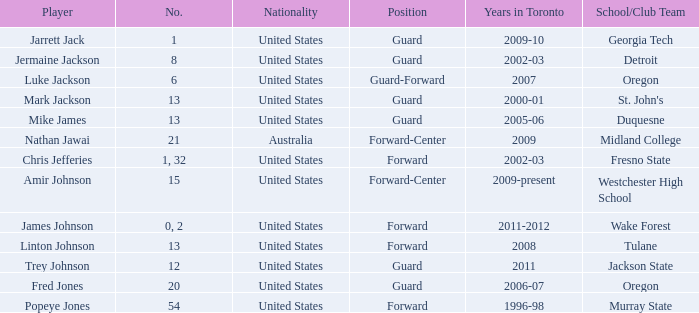On which school/group team can amir johnson be found? Westchester High School. 